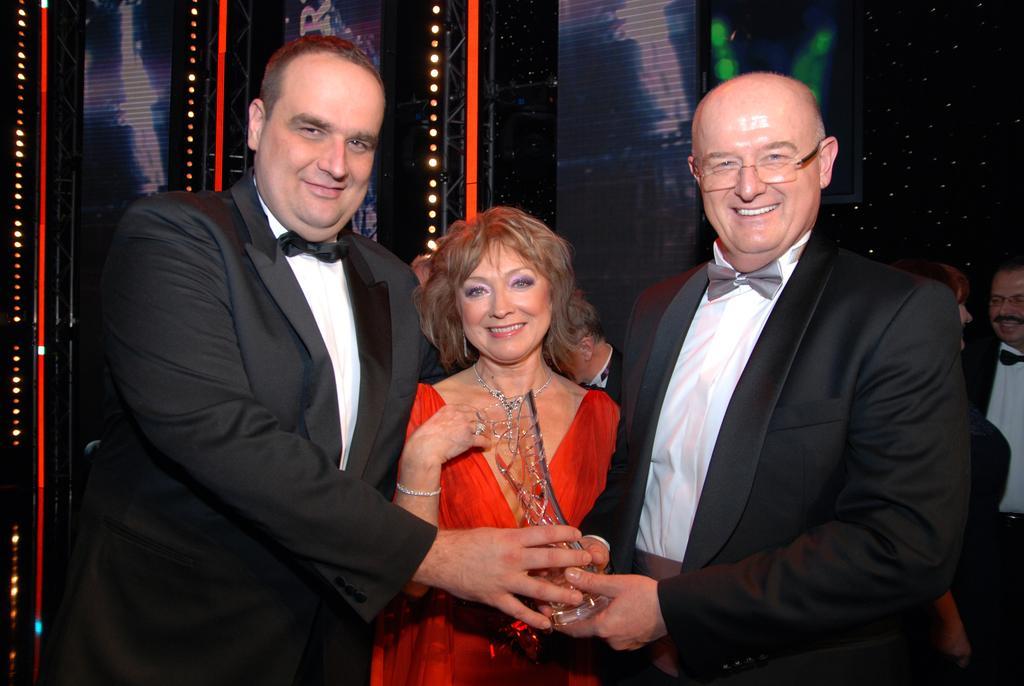In one or two sentences, can you explain what this image depicts? Here I can see two men and a woman standing, holding an award in the hands, smiling and giving pose for the picture. In the background, I can see some more people and some lights. This is an image clicked in the dark. 